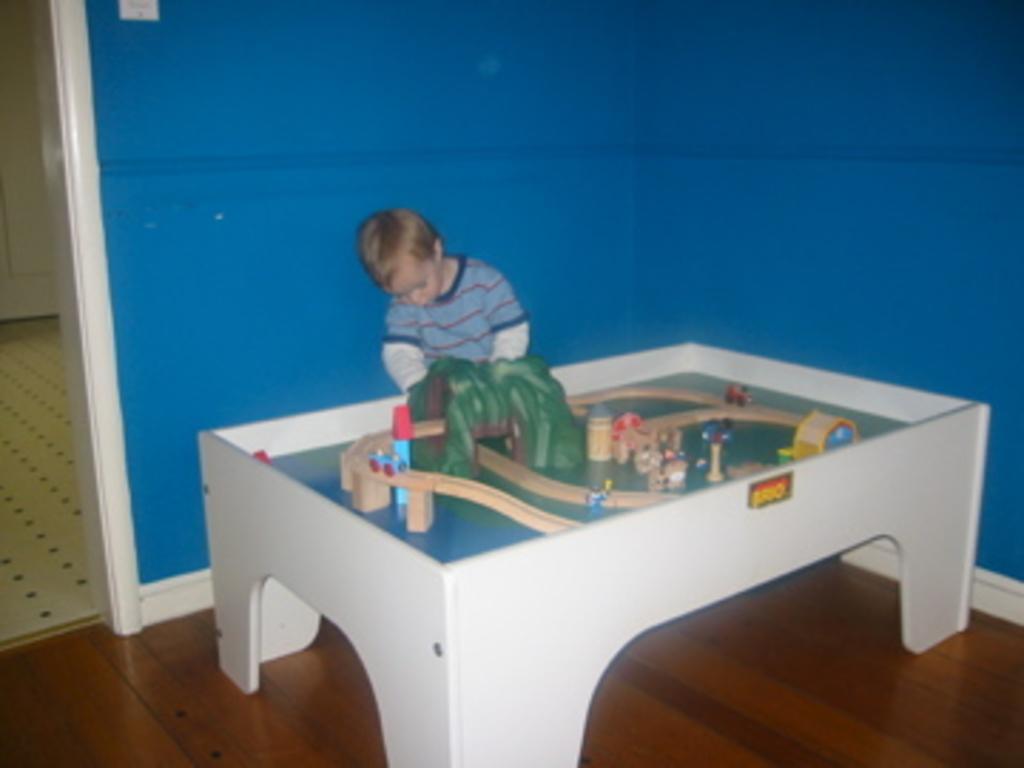Could you give a brief overview of what you see in this image? In this image I can see a child and a miniature. 